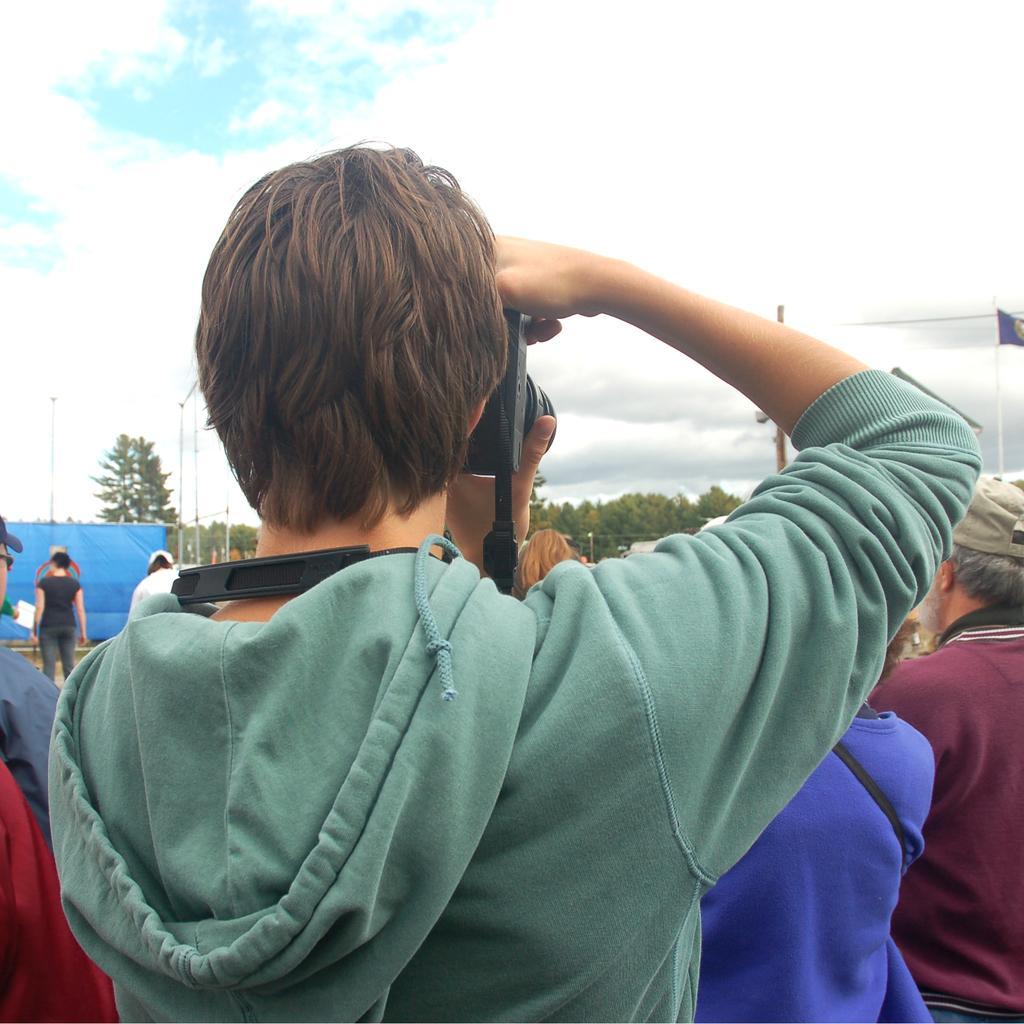Could you give a brief overview of what you see in this image? There are many people in the image. There is a flag at the right side of the image. There is a blue color object at the left side of the image. A person is holding a camera in the image. There is a blue and cloudy sky in the image. 